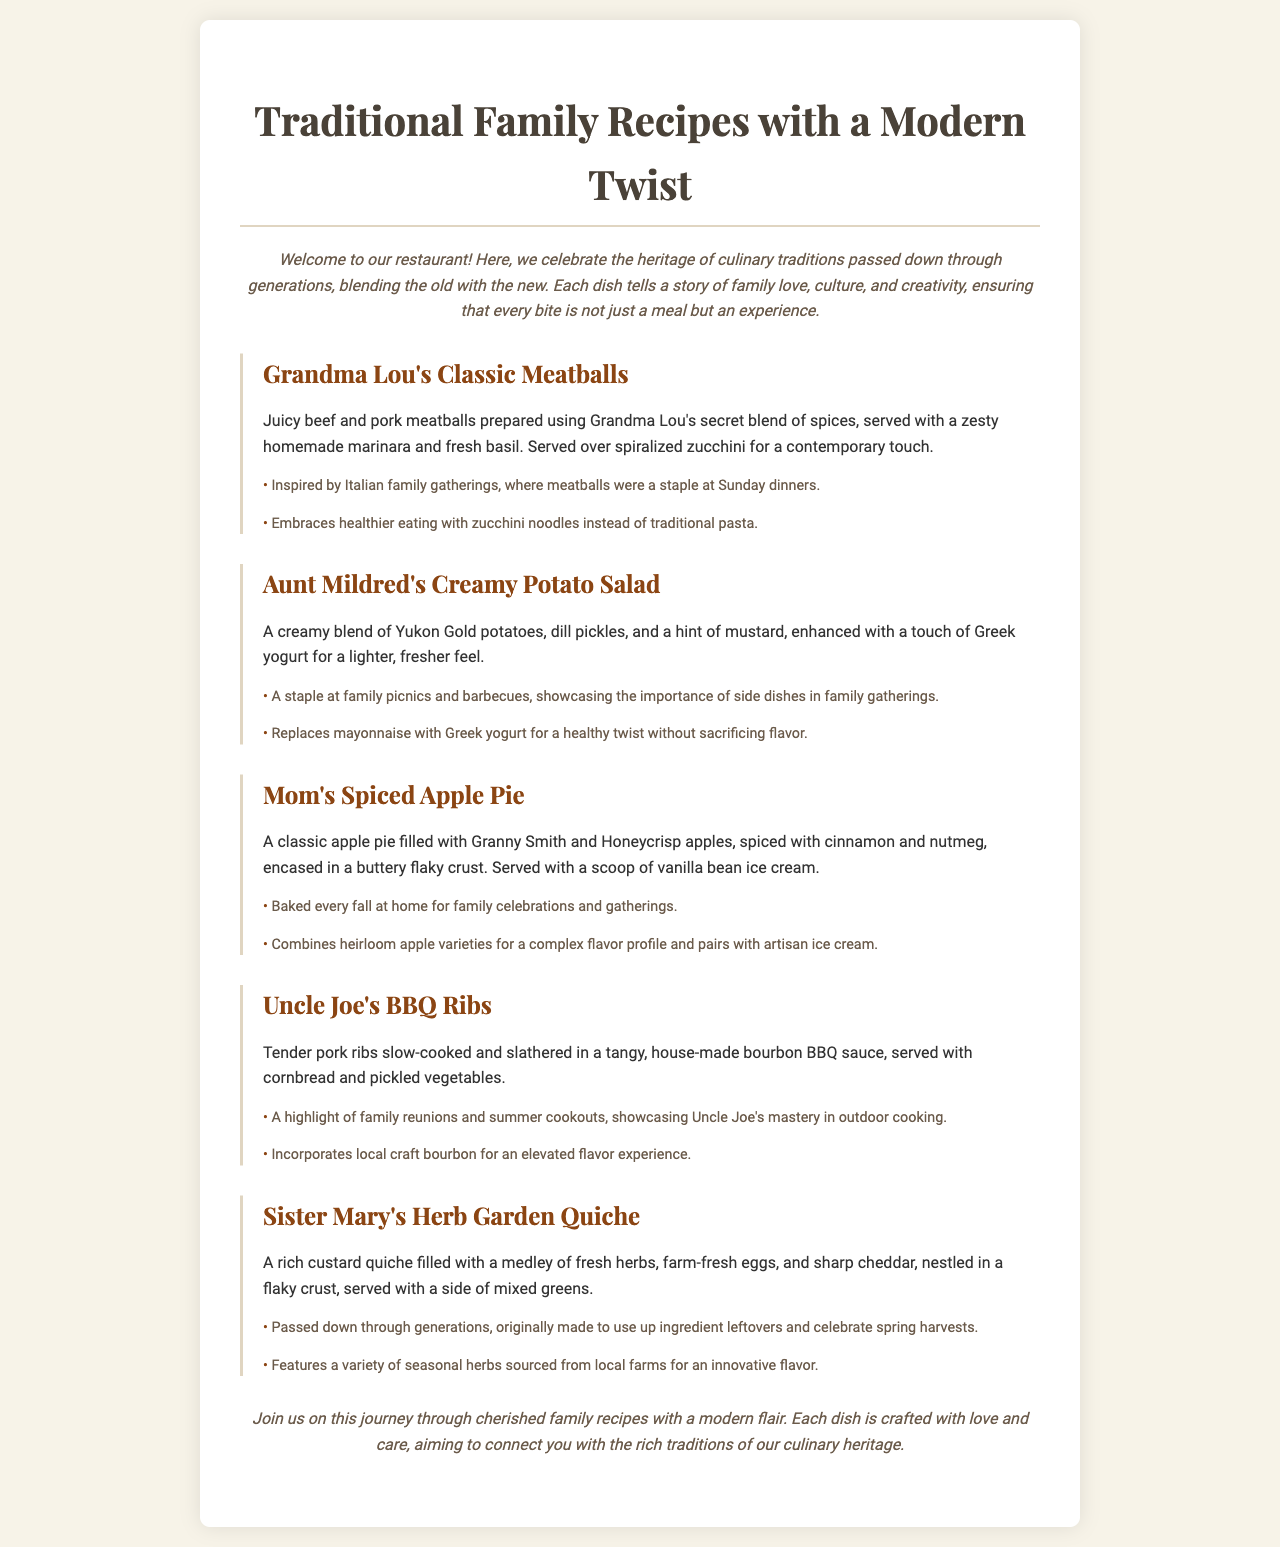What is the title of the menu? The title of the menu is prominently displayed at the top of the document.
Answer: Traditional Family Recipes with a Modern Twist How many recipes are listed in the menu? There are five distinct recipes presented in the menu section.
Answer: Five What is the main ingredient in Grandma Lou's Classic Meatballs? The description mentions that the meatballs are made with beef and pork.
Answer: Beef and pork What is the modern twist on Aunt Mildred's Creamy Potato Salad? The menu specifies that Greek yogurt is used instead of mayonnaise for a healthier option.
Answer: Greek yogurt What does Sister Mary's Herb Garden Quiche celebrate? The tradition associated with the quiche relates to using up leftover ingredients and celebrating the spring harvest.
Answer: Spring harvest What sides are served with Uncle Joe's BBQ Ribs? The description states that the BBQ ribs come with cornbread and pickled vegetables.
Answer: Cornbread and pickled vegetables What type of apples are used in Mom's Spiced Apple Pie? The ingredients list specifically mentions Granny Smith and Honeycrisp apples.
Answer: Granny Smith and Honeycrisp Where does the bourbon used in Uncle Joe's BBQ Ribs come from? The modern twist indicates that local craft bourbon is used to enhance the flavor.
Answer: Local craft bourbon What is the cooking method for Uncle Joe's BBQ Ribs? The description indicates that the ribs are slow-cooked before being served.
Answer: Slow-cooked 